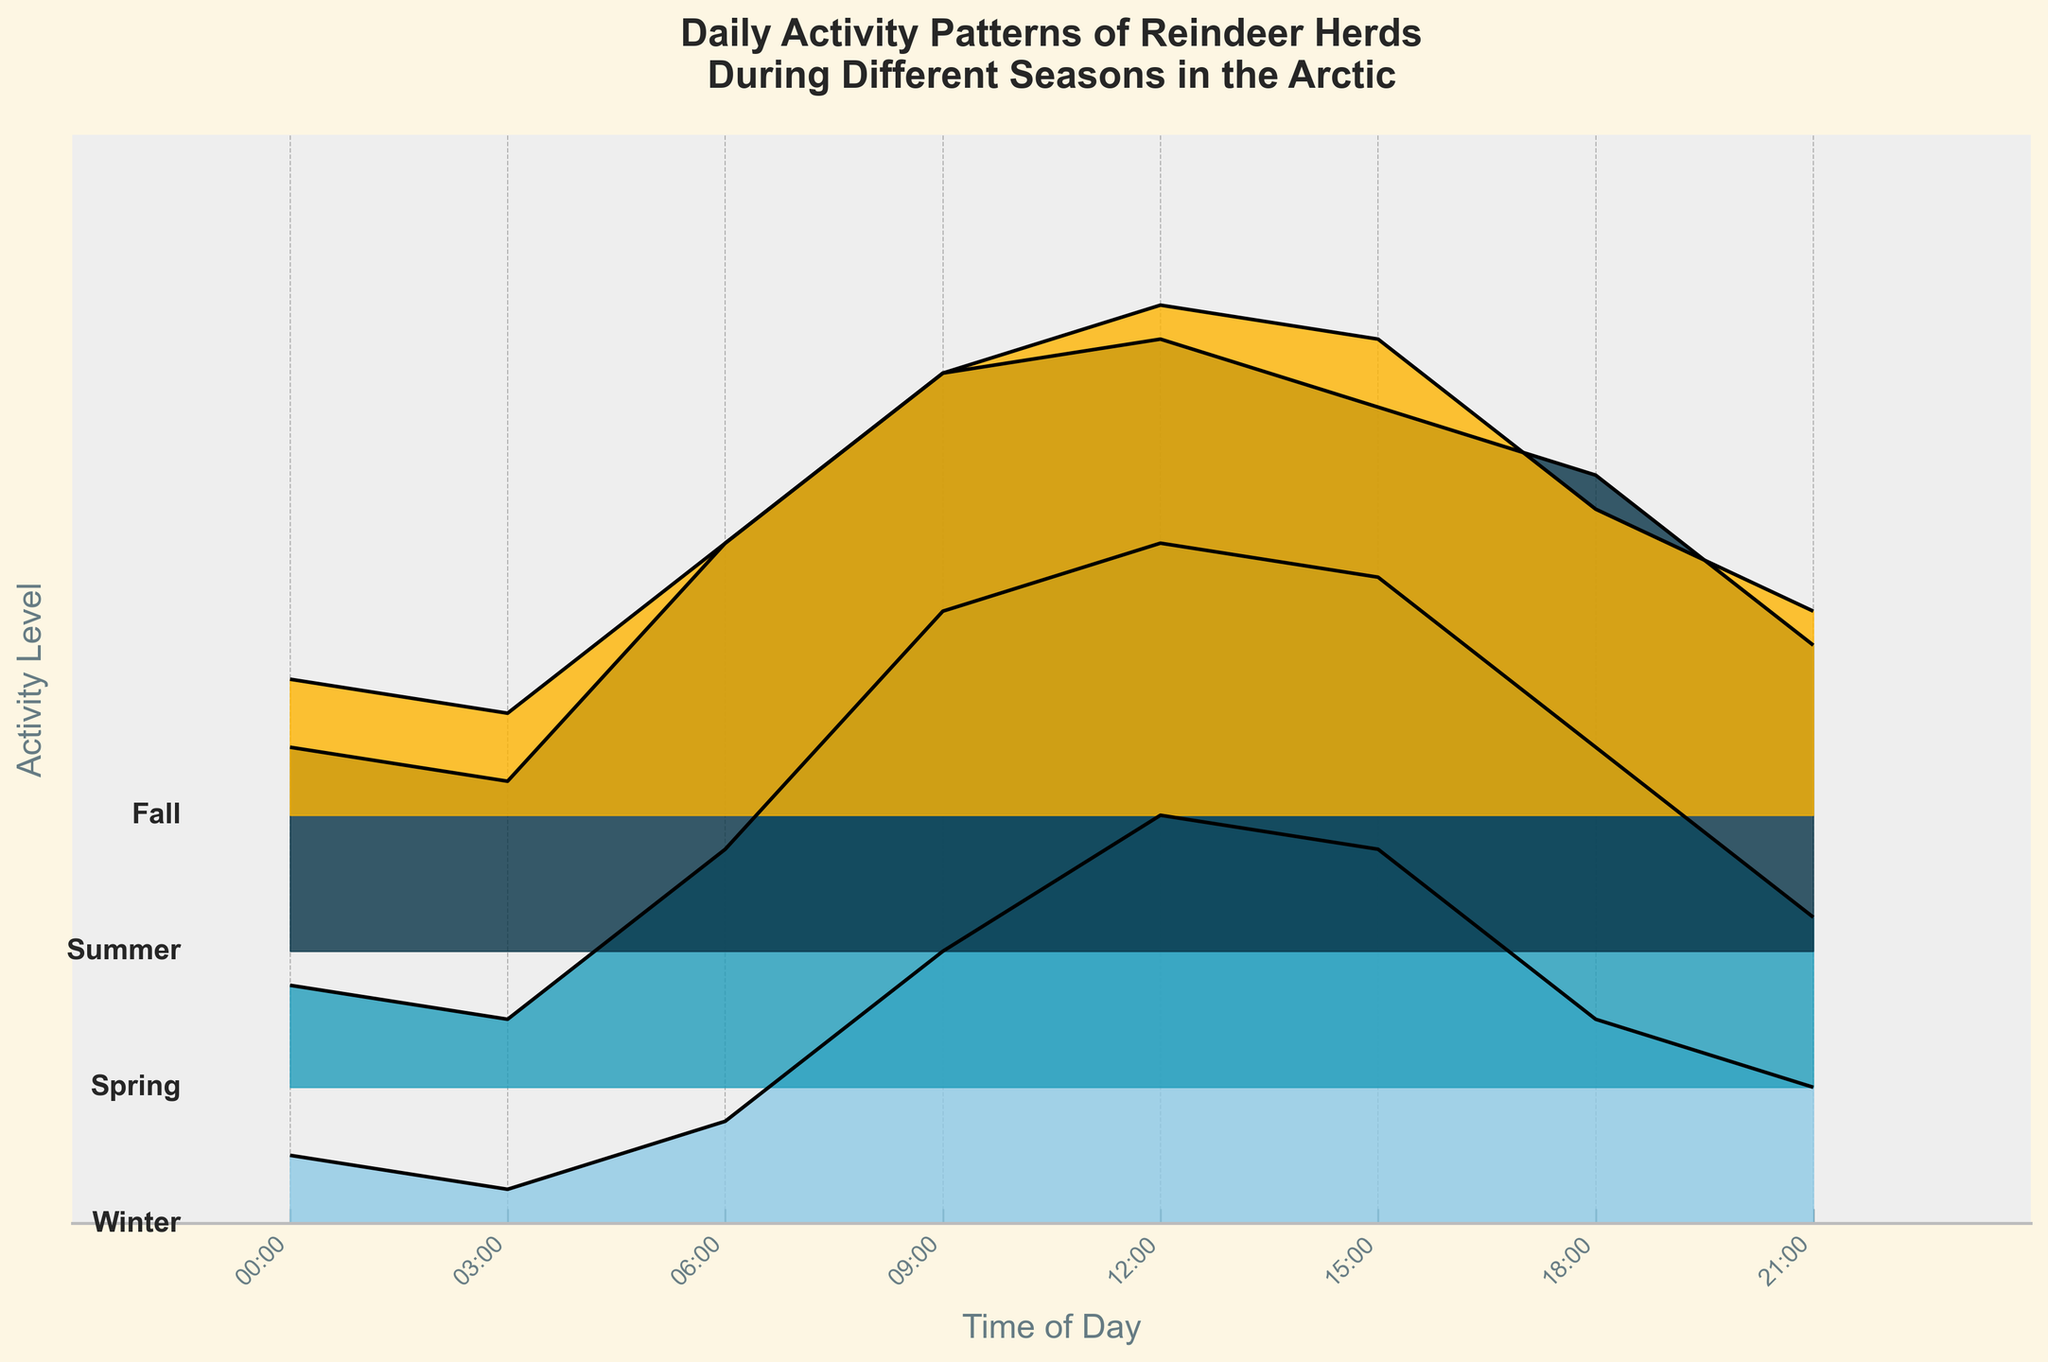What is the title of the figure? The title is usually displayed at the top of the figure. By reading the text at the top, you find the title.
Answer: Daily Activity Patterns of Reindeer Herds During Different Seasons in the Arctic How does the activity level at noon compare between winter and summer? To compare the activity levels, look at the y-values corresponding to 12:00 (noon) for both seasons. In winter, the activity level is 60, while in summer, it is 90.
Answer: Summer has a higher activity level at noon Which season shows the highest overall activity level and at what time? To determine the highest overall activity level, scan through each season's ridgeline and identify the peak points. In the data, summer at 12:00 shows the highest activity level of 90.
Answer: Summer at 12:00 At which time of day is the activity level the lowest in spring? For the lowest activity level in spring, examine the y-values for each time point in the spring ridgeline. The data indicates that 03:00 has the lowest activity level of 10.
Answer: 03:00 Are there any times of day where the activity levels are similar across all seasons? To find similar activity levels across all seasons, visually compare the heights of the ridgelines at each time point. The activity levels around 21:00 appear to be closer to each other across all the seasons.
Answer: 21:00 What trend can be observed in the daily activity pattern of reindeer from morning to afternoon during summer? To observe the trend, look at the shape of the summer ridgeline from 06:00 to 15:00. The activity level rises gradually from 60 at 06:00 to 90 at 12:00 and then slightly decreases to 80 at 15:00.
Answer: It increases until noon and then slightly decreases How does the variability in activity levels throughout the day compare between winter and fall? To compare variability, observe the range of activity levels from the lowest to highest point in the ridgelines for winter and fall. Winter ranges from 5 to 60, and fall ranges from 15 to 75.
Answer: Fall shows higher variability Which season has the most gradual rise in activity levels in the morning? To find the most gradual rise, compare the slopes of the lines from midnight to the next peak point in each season's ridgeline. Spring shows a gradual rise from 03:00 to 09:00.
Answer: Spring What is the difference in activity levels between morning (09:00) and evening (18:00) during fall? For the difference, subtract the activity level at 18:00 from that at 09:00 in the fall ridgeline. The activity level at 09:00 is 65 and at 18:00 is 45, so the difference is 65 - 45.
Answer: 20 